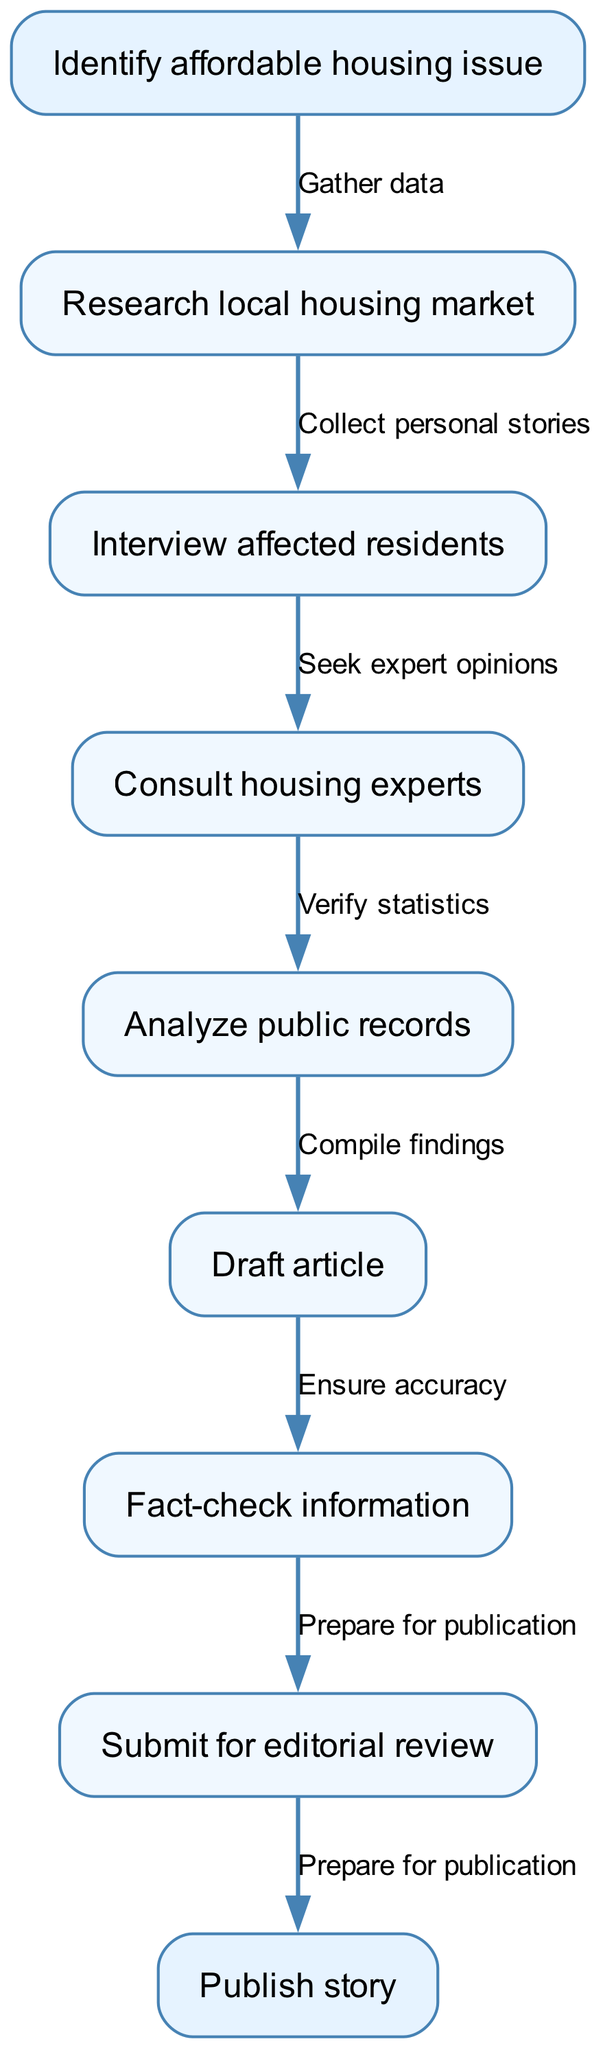What is the first step in the process? The first step is indicated in the diagram as "Identify affordable housing issue," which is the starting node in the flow chart.
Answer: Identify affordable housing issue How many nodes are in the diagram? The diagram contains a total of 8 nodes: 1 start node, 6 intermediate nodes, and 1 end node.
Answer: 8 What happens after "Research local housing market"? Following "Research local housing market," the next node is "Interview affected residents," which indicates that the process transitions to gathering personal stories from those impacted.
Answer: Interview affected residents What is the last step in the reporting process? The last step in the process is "Publish story," which is the end node of the flow chart indicating the final action taken after completing the earlier steps.
Answer: Publish story Which edge connects "Draft article" and "Fact-check information"? The edge that connects these two nodes signifies the action taken, which is not specified in the text data provided but is assumed to be the logical flow from drafting to verifying content before publication.
Answer: Ensure accuracy How does the flow from "Consult housing experts" unfold? After consulting with housing experts, the next steps involve analyzing the findings with public records, confirming the action is towards gathering deeper insights and data verification.
Answer: Analyze public records What type of information is collected during "Interview affected residents"? During "Interview affected residents," the information collected is personal stories that highlight individual experiences and challenges faced in the housing crisis.
Answer: Collect personal stories What is the relationship between "Analyze public records" and "Submit for editorial review"? "Analyze public records" is a preceding step that ensures that all findings are well-supported and verified, leading logically to the step of submitting the drafted article for editorial review.
Answer: Compile findings 